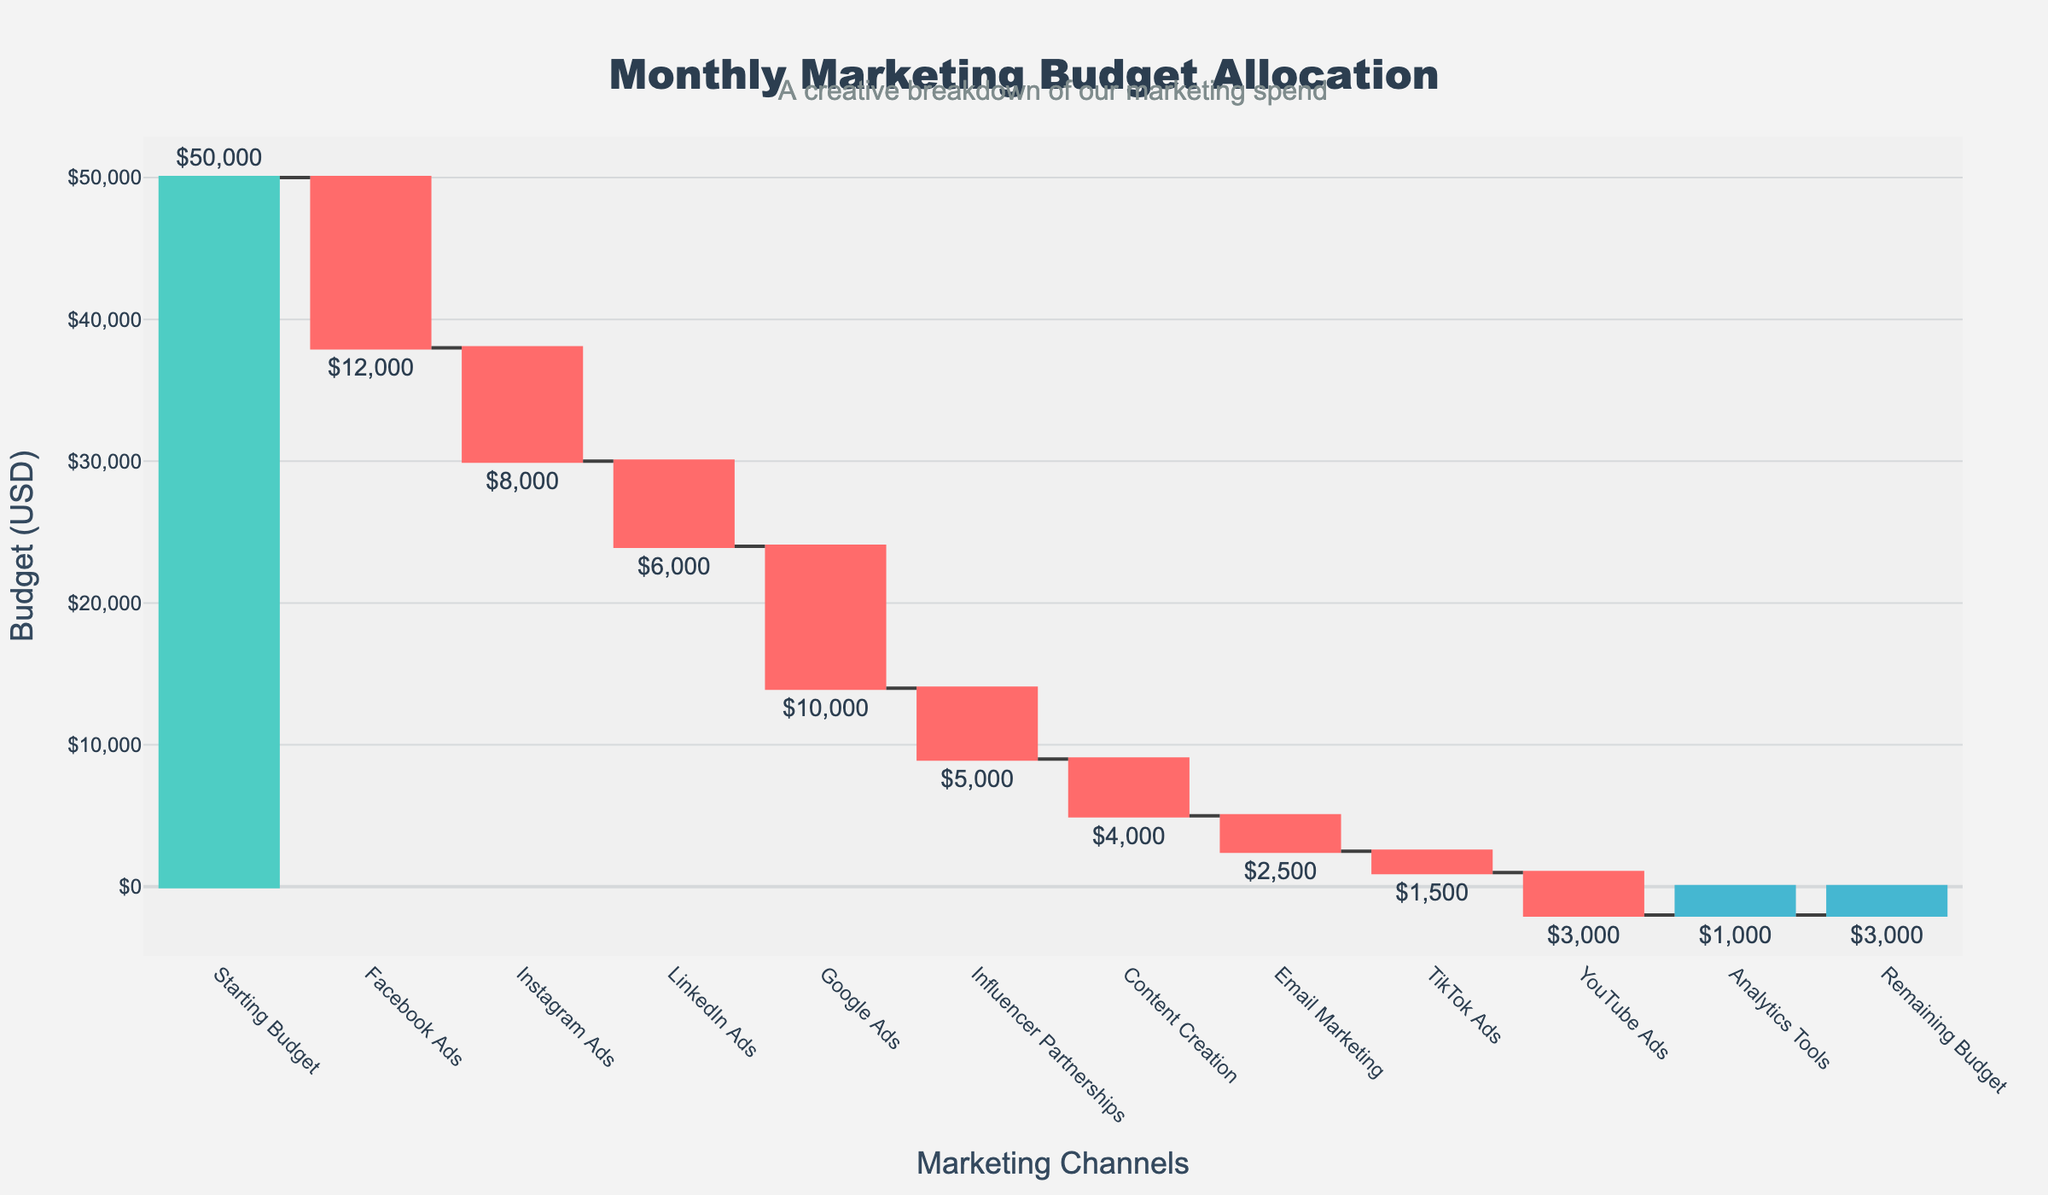What is the total starting budget? The title indicates the figure represents "Monthly Marketing Budget Allocation" and the first data point is "Starting Budget" which shows $50,000
Answer: $50,000 Which channel has the highest individual expenditure? By looking at the relative decreases in the waterfall chart, the largest drop is linked to Facebook Ads, showing an expenditure of $12,000
Answer: Facebook Ads How much budget remains after accounting for all expenditures? The last data point in the chart is "Remaining Budget," indicating $3,000 left
Answer: $3,000 How much is spent on Google Ads and YouTube Ads combined? From the waterfall chart, Google Ads shows a reduction of $10,000 and YouTube Ads shows a reduction of $3,000. Summing these up, $10,000 + $3,000 = $13,000
Answer: $13,000 What is the total expenditure on social media ads (Facebook, Instagram, LinkedIn, TikTok)? Facebook Ads: $12,000, Instagram Ads: $8,000, LinkedIn Ads: $6,000, TikTok Ads: $1,500. Summing all these values: $12,000 + $8,000 + $6,000 + $1,500 = $27,500
Answer: $27,500 Which types of ads have a lower budget allocation than YouTube Ads? YouTube Ads have a budget reduction of $3,000. Analyzing the chart, the following channels have lower budgets: TikTok Ads $1,500, Analytics Tools $1,000, Email Marketing $2,500.
Answer: TikTok Ads, Analytics Tools, Email Marketing Out of all the channels, which one has the smallest budget allocation? By referring to the waterfall chart, the channel with the smallest financial outlay is Analytics Tools at $1,000
Answer: Analytics Tools How much more is spent on LinkedIn Ads compared to Influencer Partnerships? LinkedIn Ads have a reduction of $6,000, while Influencer Partnerships have $5,000. The difference is $6,000 - $5,000 = $1,000
Answer: $1,000 What is the total amount allocated to Influencer Partnerships and Content Creation combined? Influencer Partnerships show a reduction of $5,000 and Content Creation shows a reduction of $4,000. Summing these values: $5,000 + $4,000 = $9,000
Answer: $9,000 Which has higher expenditure: Email Marketing or TikTok Ads? By analyzing the figure, Email Marketing expenses amount to $2,500, whereas TikTok Ads is $1,500, making Email Marketing higher
Answer: Email Marketing 